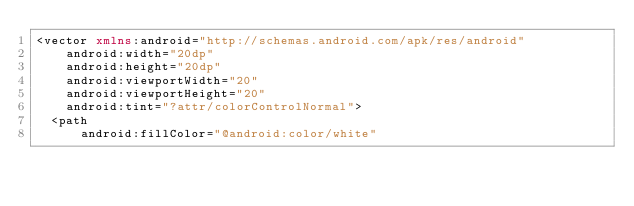<code> <loc_0><loc_0><loc_500><loc_500><_XML_><vector xmlns:android="http://schemas.android.com/apk/res/android"
    android:width="20dp"
    android:height="20dp"
    android:viewportWidth="20"
    android:viewportHeight="20"
    android:tint="?attr/colorControlNormal">
  <path
      android:fillColor="@android:color/white"</code> 